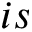<formula> <loc_0><loc_0><loc_500><loc_500>i s</formula> 